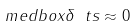Convert formula to latex. <formula><loc_0><loc_0><loc_500><loc_500>\ m e d b o x { \delta { \ t s } \approx 0 }</formula> 